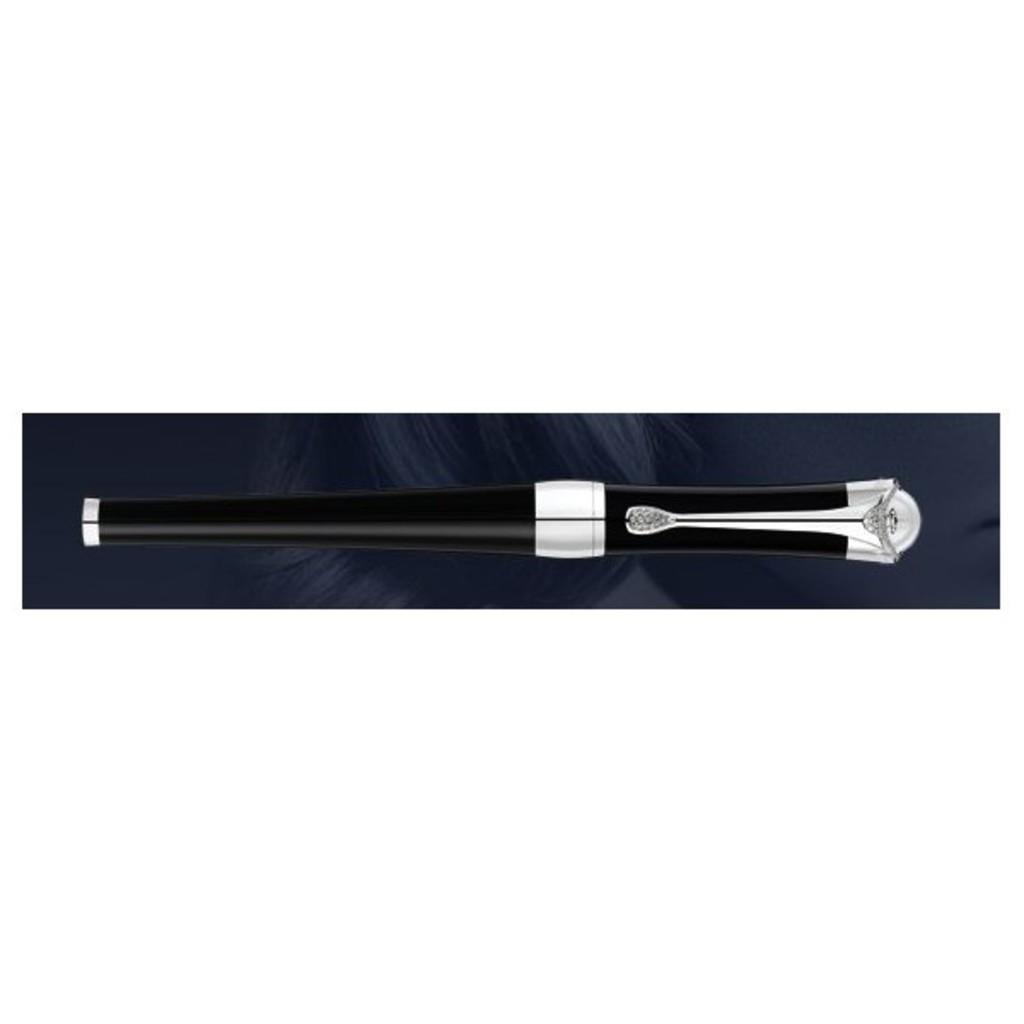In one or two sentences, can you explain what this image depicts? In this image there is a pen. 